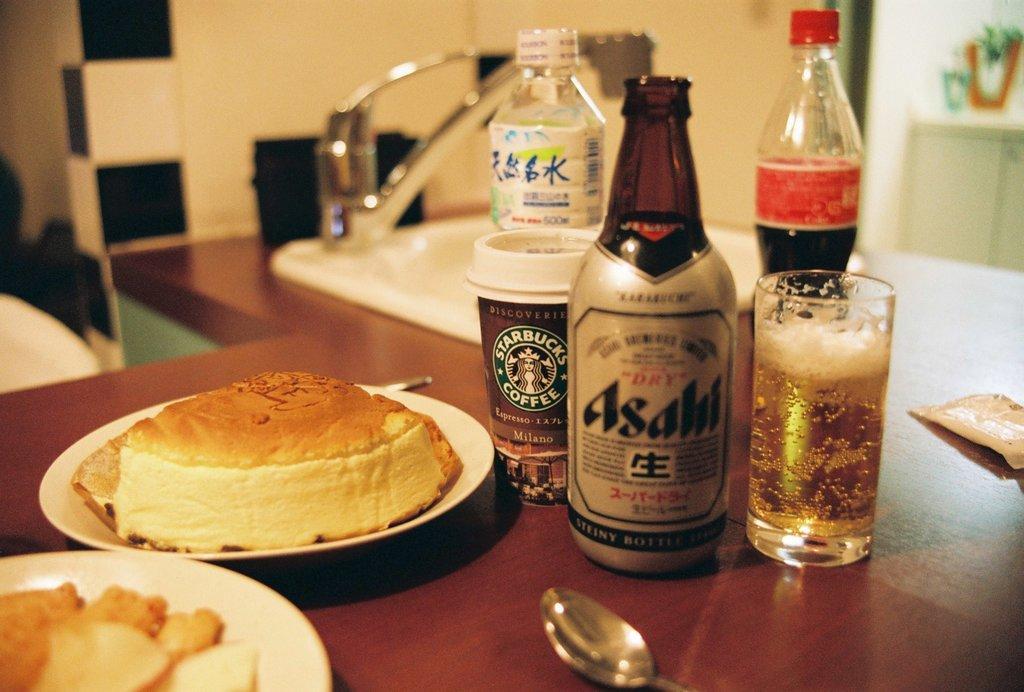Describe this image in one or two sentences. In this picture there is a table in the center, on the table there are bottles, glass, can, spoon, plates and some food. In the background there is a sink. Towards the right corner there is a desk, on the desk there are some plants. 